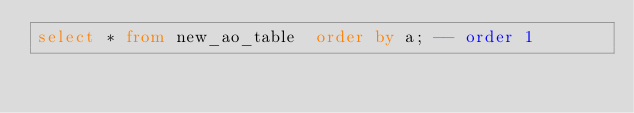Convert code to text. <code><loc_0><loc_0><loc_500><loc_500><_SQL_>select * from new_ao_table  order by a; -- order 1
</code> 